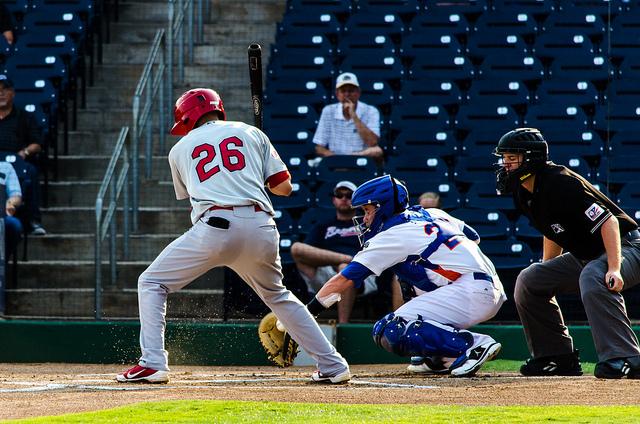What is in the batter's pocket?
Keep it brief. Gloves. Is this pitch a strike?
Answer briefly. No. What number is on the batter's shirt?
Short answer required. 26. 